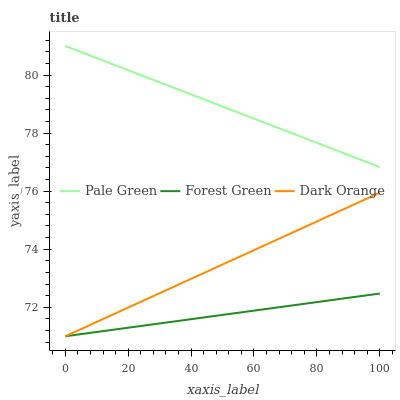Does Forest Green have the minimum area under the curve?
Answer yes or no. Yes. Does Pale Green have the maximum area under the curve?
Answer yes or no. Yes. Does Pale Green have the minimum area under the curve?
Answer yes or no. No. Does Forest Green have the maximum area under the curve?
Answer yes or no. No. Is Dark Orange the smoothest?
Answer yes or no. Yes. Is Forest Green the roughest?
Answer yes or no. Yes. Is Pale Green the smoothest?
Answer yes or no. No. Is Pale Green the roughest?
Answer yes or no. No. Does Dark Orange have the lowest value?
Answer yes or no. Yes. Does Pale Green have the lowest value?
Answer yes or no. No. Does Pale Green have the highest value?
Answer yes or no. Yes. Does Forest Green have the highest value?
Answer yes or no. No. Is Forest Green less than Pale Green?
Answer yes or no. Yes. Is Pale Green greater than Dark Orange?
Answer yes or no. Yes. Does Forest Green intersect Dark Orange?
Answer yes or no. Yes. Is Forest Green less than Dark Orange?
Answer yes or no. No. Is Forest Green greater than Dark Orange?
Answer yes or no. No. Does Forest Green intersect Pale Green?
Answer yes or no. No. 